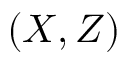Convert formula to latex. <formula><loc_0><loc_0><loc_500><loc_500>( X , Z )</formula> 